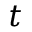<formula> <loc_0><loc_0><loc_500><loc_500>t</formula> 